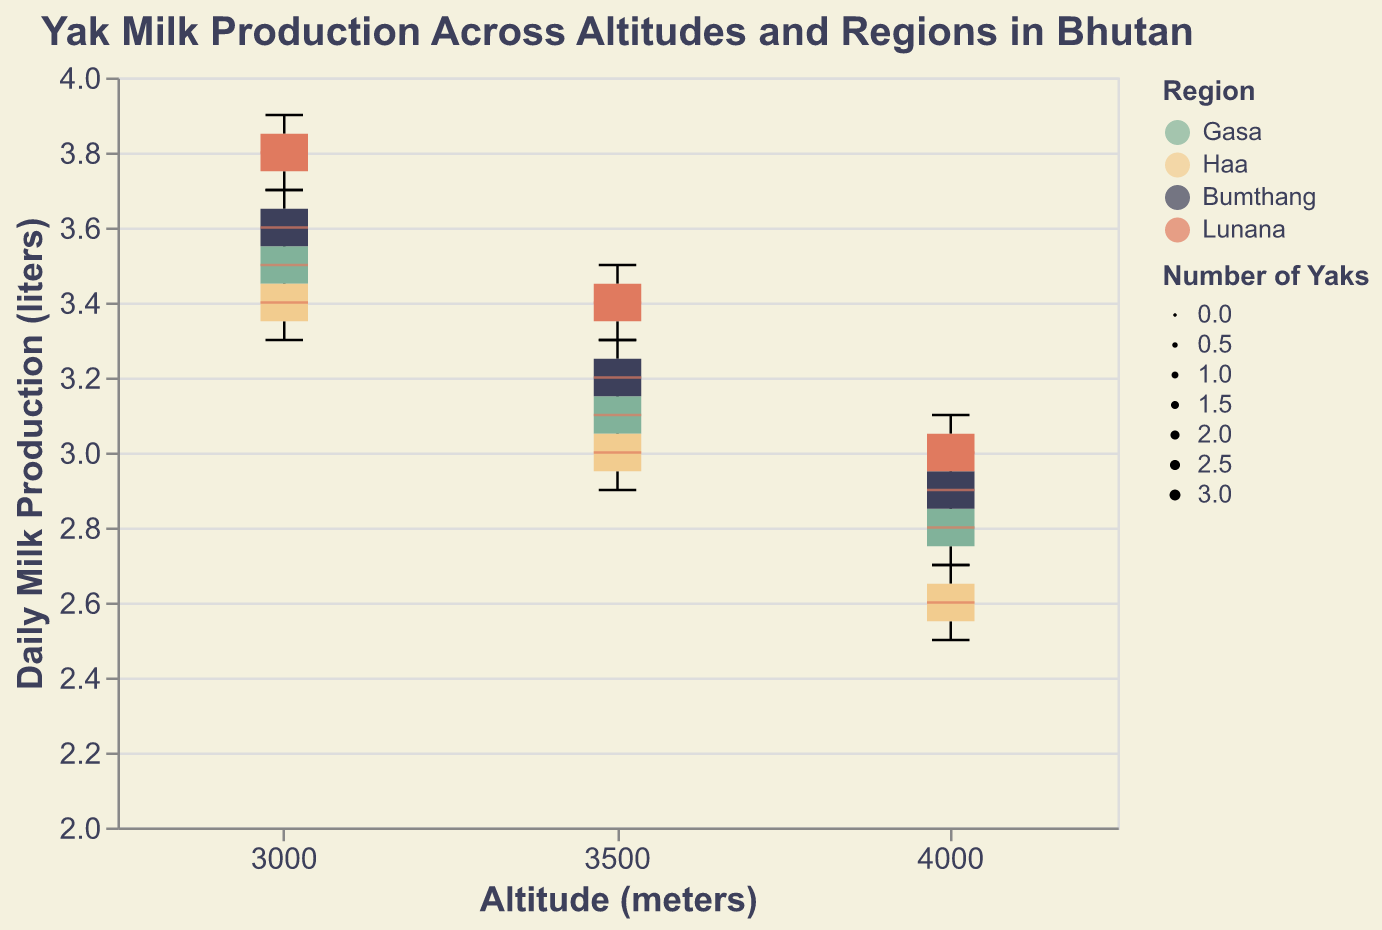What's the title of the chart? The title is typically visible at the top of the chart. In this case, the title is "Yak Milk Production Across Altitudes and Regions in Bhutan."
Answer: Yak Milk Production Across Altitudes and Regions in Bhutan How many regions are represented in the chart? By looking at the color legend of the chart, we can see four distinct colors, each representing a different region in Bhutan: Gasa, Haa, Bumthang, and Lunana.
Answer: 4 Which region has the highest median daily milk production at 3000 meters? By examining the median lines in each box plot at 3000 meters, the region with the highest median will be the one with the highest horizontal line within that altitude class. Lunana's median at 3000 meters is highest.
Answer: Lunana How does the spread of daily milk production compare between 3000 meters and 4000 meters in Gasa? For comparison, we need to look at the interquartile ranges and the minimum and maximum "whiskers" of the box plots for Gasa at 3000 meters and 4000 meters. The spread at 3000 meters is wider than at 4000 meters.
Answer: Wider at 3000 meters What can you say about the number of yaks at each altitude level for Bumthang? The width of the box plots indicates the number of data points or yaks. By comparing the width of the boxes at 3000, 3500, and 4000 meters for Bumthang, 3000 meters has the widest box plot, indicating the most yaks, followed by 3500 meters, and 4000 meters has the least.
Answer: Most at 3000 meters, least at 4000 meters Which region has the lowest minimum daily milk production at 4000 meters? To find the lowest minimum daily milk production, look at the bottom of the "whiskers" at 4000 meters for each region. Haa has the lowest minimum as its whisker bottom is the lowest.
Answer: Haa Is there any region where the daily milk production is consistently decreasing with increasing altitude? By analyzing the median lines of each region across the three altitude levels (3000m, 3500m, 4000m), if all medians consistently decrease, then milk production is consistently decreasing with altitude. In Haa, the medians decrease from 3000m to 3500m to 4000m.
Answer: Haa What is the range of daily milk production for Lunana at 3500 meters? The range can be determined by subtracting the minimum value (bottom whisker) from the maximum value (top whisker) for Lunana at 3500 meters. The approximate values appear to be between 3.3 and 3.5 liters.
Answer: 0.2 liters Which altitude level has the smallest interquartile range for any region? The smallest interquartile range (IQR) can be found by identifying the narrowest box in the chart at any altitude level. The box at 3000 meters for the Haa region appears to be the narrowest among all altitudes and regions.
Answer: 3000 meters in Haa 